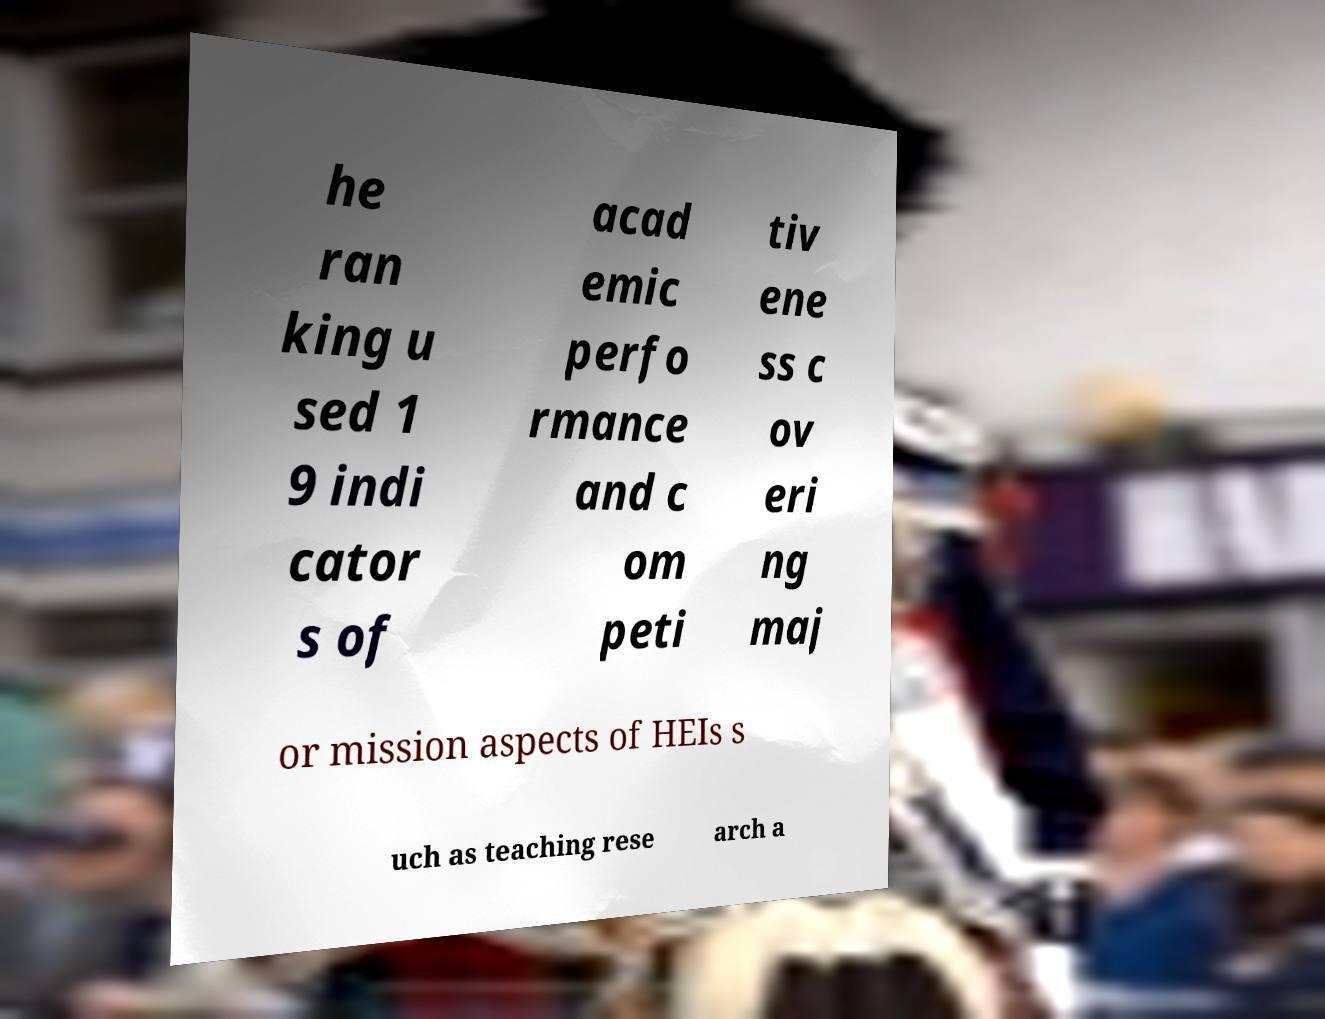There's text embedded in this image that I need extracted. Can you transcribe it verbatim? he ran king u sed 1 9 indi cator s of acad emic perfo rmance and c om peti tiv ene ss c ov eri ng maj or mission aspects of HEIs s uch as teaching rese arch a 